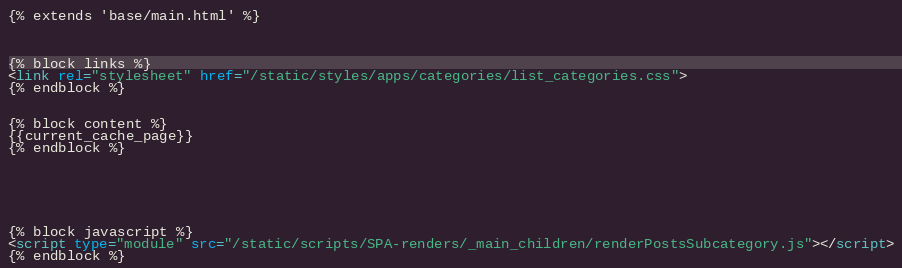<code> <loc_0><loc_0><loc_500><loc_500><_HTML_>{% extends 'base/main.html' %}



{% block links %}
<link rel="stylesheet" href="/static/styles/apps/categories/list_categories.css">
{% endblock %}


{% block content %}
{{current_cache_page}}
{% endblock %}






{% block javascript %}
<script type="module" src="/static/scripts/SPA-renders/_main_children/renderPostsSubcategory.js"></script>
{% endblock %}</code> 